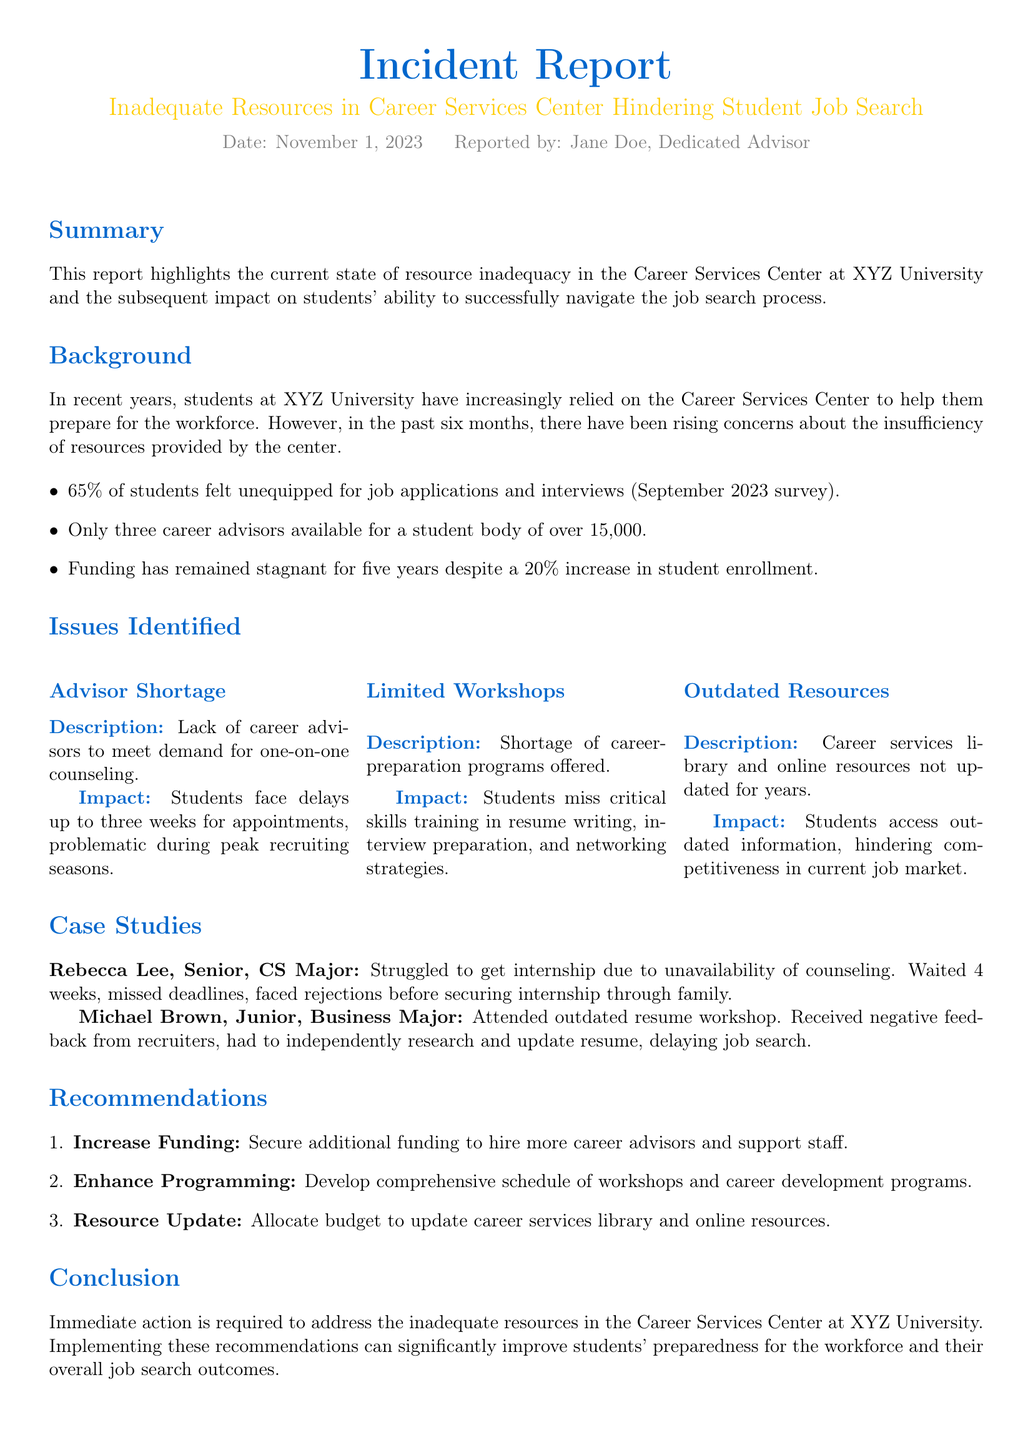What is the date of the incident report? The date is specified at the beginning of the report as November 1, 2023.
Answer: November 1, 2023 Who reported the incident? The report identifies Jane Doe as the person who reported the incident.
Answer: Jane Doe What percentage of students felt unequipped for job applications? A survey conducted in September 2023 indicated that 65% of students felt this way.
Answer: 65% How many career advisors are available for the student body? The report states that there are only three career advisors for over 15,000 students.
Answer: Three What is the maximum waiting time for students to get an appointment? The report mentions that students face delays of up to three weeks for appointments.
Answer: Three weeks Which major did Rebecca Lee study? The report identifies Rebecca Lee as a Senior majoring in Computer Science.
Answer: CS Major What type of programs are lacking at the Career Services Center? The report highlights a shortage of career-preparation programs offered at the center.
Answer: Career-preparation programs What is one of the recommendations made in the report? The recommendations section suggests increasing funding for the Career Services Center.
Answer: Increase Funding What specific issue is associated with outdated resources? Students access outdated information, which hinders their competitiveness in the job market.
Answer: Hinders competitiveness in the job market 